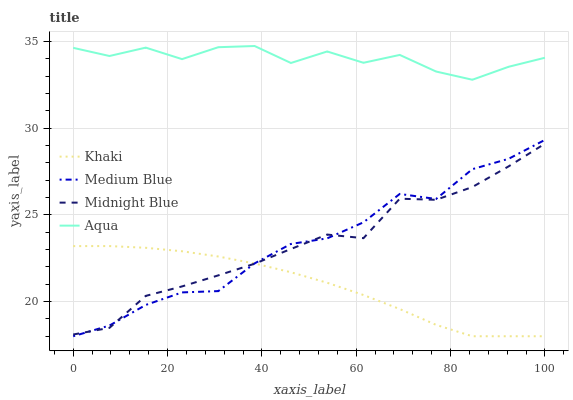Does Khaki have the minimum area under the curve?
Answer yes or no. Yes. Does Aqua have the maximum area under the curve?
Answer yes or no. Yes. Does Medium Blue have the minimum area under the curve?
Answer yes or no. No. Does Medium Blue have the maximum area under the curve?
Answer yes or no. No. Is Khaki the smoothest?
Answer yes or no. Yes. Is Aqua the roughest?
Answer yes or no. Yes. Is Medium Blue the smoothest?
Answer yes or no. No. Is Medium Blue the roughest?
Answer yes or no. No. Does Khaki have the lowest value?
Answer yes or no. Yes. Does Midnight Blue have the lowest value?
Answer yes or no. No. Does Aqua have the highest value?
Answer yes or no. Yes. Does Medium Blue have the highest value?
Answer yes or no. No. Is Medium Blue less than Aqua?
Answer yes or no. Yes. Is Aqua greater than Medium Blue?
Answer yes or no. Yes. Does Medium Blue intersect Khaki?
Answer yes or no. Yes. Is Medium Blue less than Khaki?
Answer yes or no. No. Is Medium Blue greater than Khaki?
Answer yes or no. No. Does Medium Blue intersect Aqua?
Answer yes or no. No. 